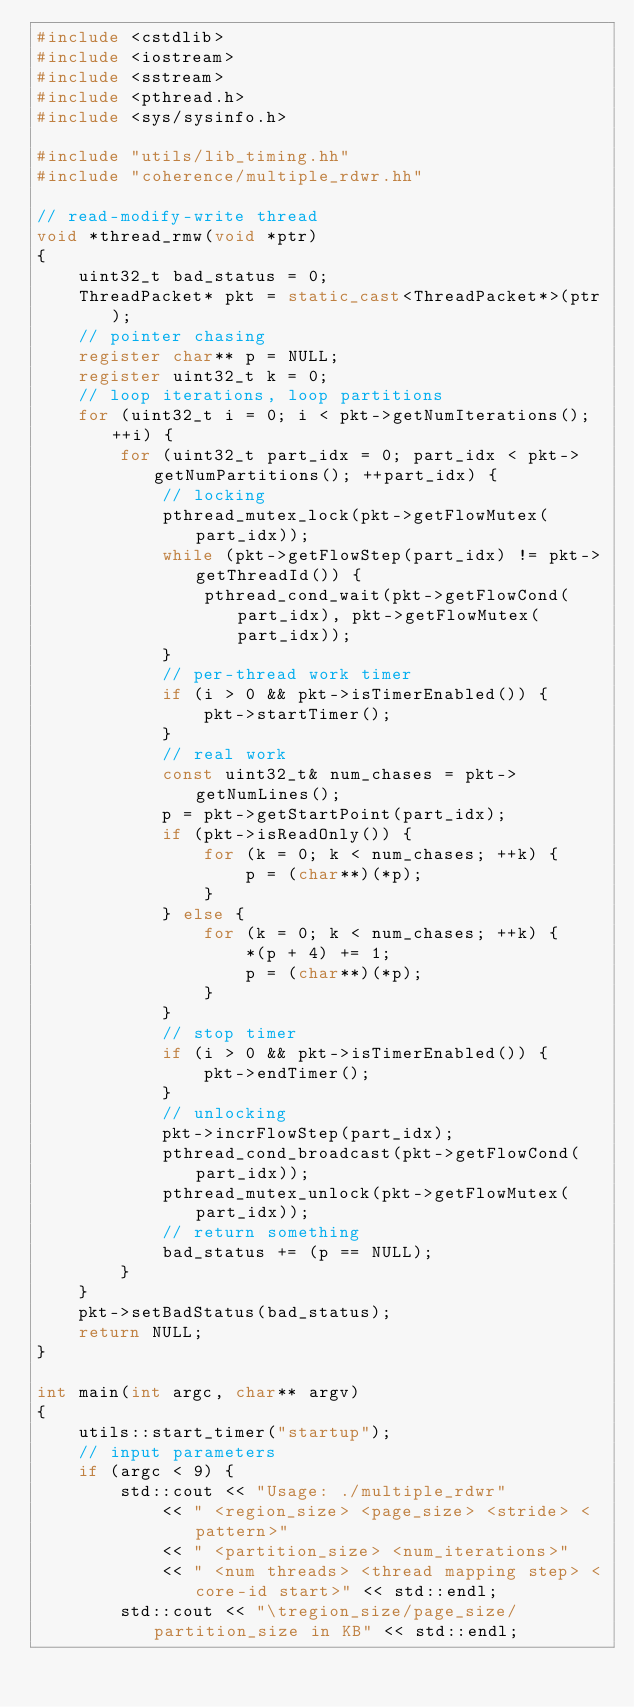<code> <loc_0><loc_0><loc_500><loc_500><_C++_>#include <cstdlib>
#include <iostream>
#include <sstream>
#include <pthread.h>
#include <sys/sysinfo.h>

#include "utils/lib_timing.hh"
#include "coherence/multiple_rdwr.hh"

// read-modify-write thread
void *thread_rmw(void *ptr)
{
    uint32_t bad_status = 0;
    ThreadPacket* pkt = static_cast<ThreadPacket*>(ptr);
    // pointer chasing
    register char** p = NULL;
    register uint32_t k = 0;
    // loop iterations, loop partitions
    for (uint32_t i = 0; i < pkt->getNumIterations(); ++i) {
        for (uint32_t part_idx = 0; part_idx < pkt->getNumPartitions(); ++part_idx) {
            // locking
            pthread_mutex_lock(pkt->getFlowMutex(part_idx));
            while (pkt->getFlowStep(part_idx) != pkt->getThreadId()) {
                pthread_cond_wait(pkt->getFlowCond(part_idx), pkt->getFlowMutex(part_idx));
            }
            // per-thread work timer
            if (i > 0 && pkt->isTimerEnabled()) {
                pkt->startTimer();
            }
            // real work
            const uint32_t& num_chases = pkt->getNumLines();
            p = pkt->getStartPoint(part_idx);
            if (pkt->isReadOnly()) {
                for (k = 0; k < num_chases; ++k) {
                    p = (char**)(*p);
                }
            } else {
                for (k = 0; k < num_chases; ++k) {
                    *(p + 4) += 1;
                    p = (char**)(*p);
                }
            }
            // stop timer
            if (i > 0 && pkt->isTimerEnabled()) {
                pkt->endTimer();
            }
            // unlocking
            pkt->incrFlowStep(part_idx);
            pthread_cond_broadcast(pkt->getFlowCond(part_idx));
            pthread_mutex_unlock(pkt->getFlowMutex(part_idx));
            // return something
            bad_status += (p == NULL);
        }
    }
    pkt->setBadStatus(bad_status);
    return NULL;
}

int main(int argc, char** argv)
{
    utils::start_timer("startup");
    // input parameters
    if (argc < 9) {
        std::cout << "Usage: ./multiple_rdwr"
            << " <region_size> <page_size> <stride> <pattern>"
            << " <partition_size> <num_iterations>"
            << " <num threads> <thread mapping step> <core-id start>" << std::endl;
        std::cout << "\tregion_size/page_size/partition_size in KB" << std::endl;</code> 